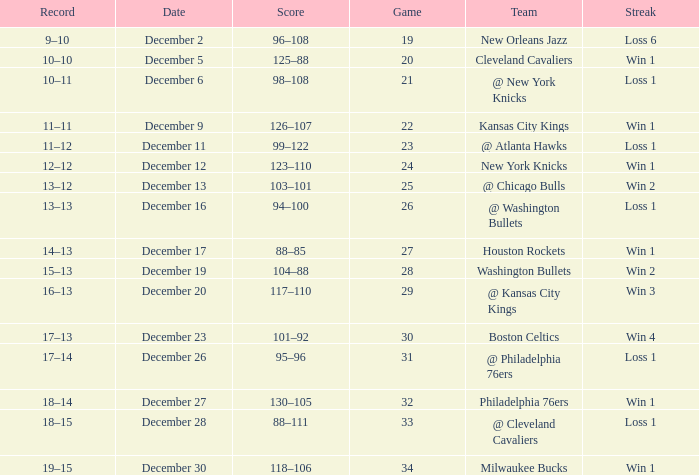What is the Streak on December 30? Win 1. 